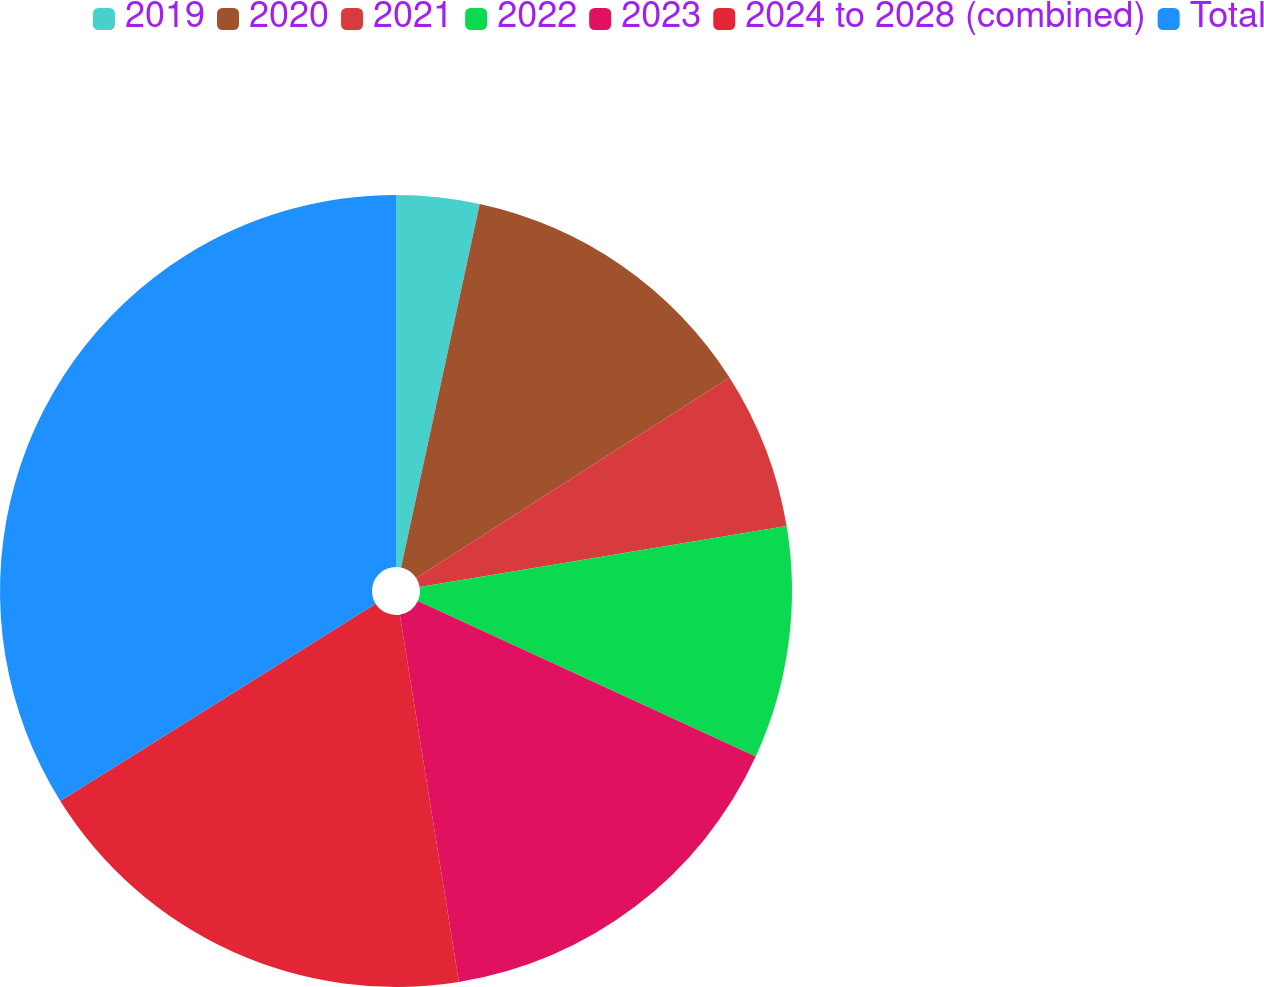<chart> <loc_0><loc_0><loc_500><loc_500><pie_chart><fcel>2019<fcel>2020<fcel>2021<fcel>2022<fcel>2023<fcel>2024 to 2028 (combined)<fcel>Total<nl><fcel>3.39%<fcel>12.54%<fcel>6.44%<fcel>9.49%<fcel>15.59%<fcel>18.64%<fcel>33.89%<nl></chart> 